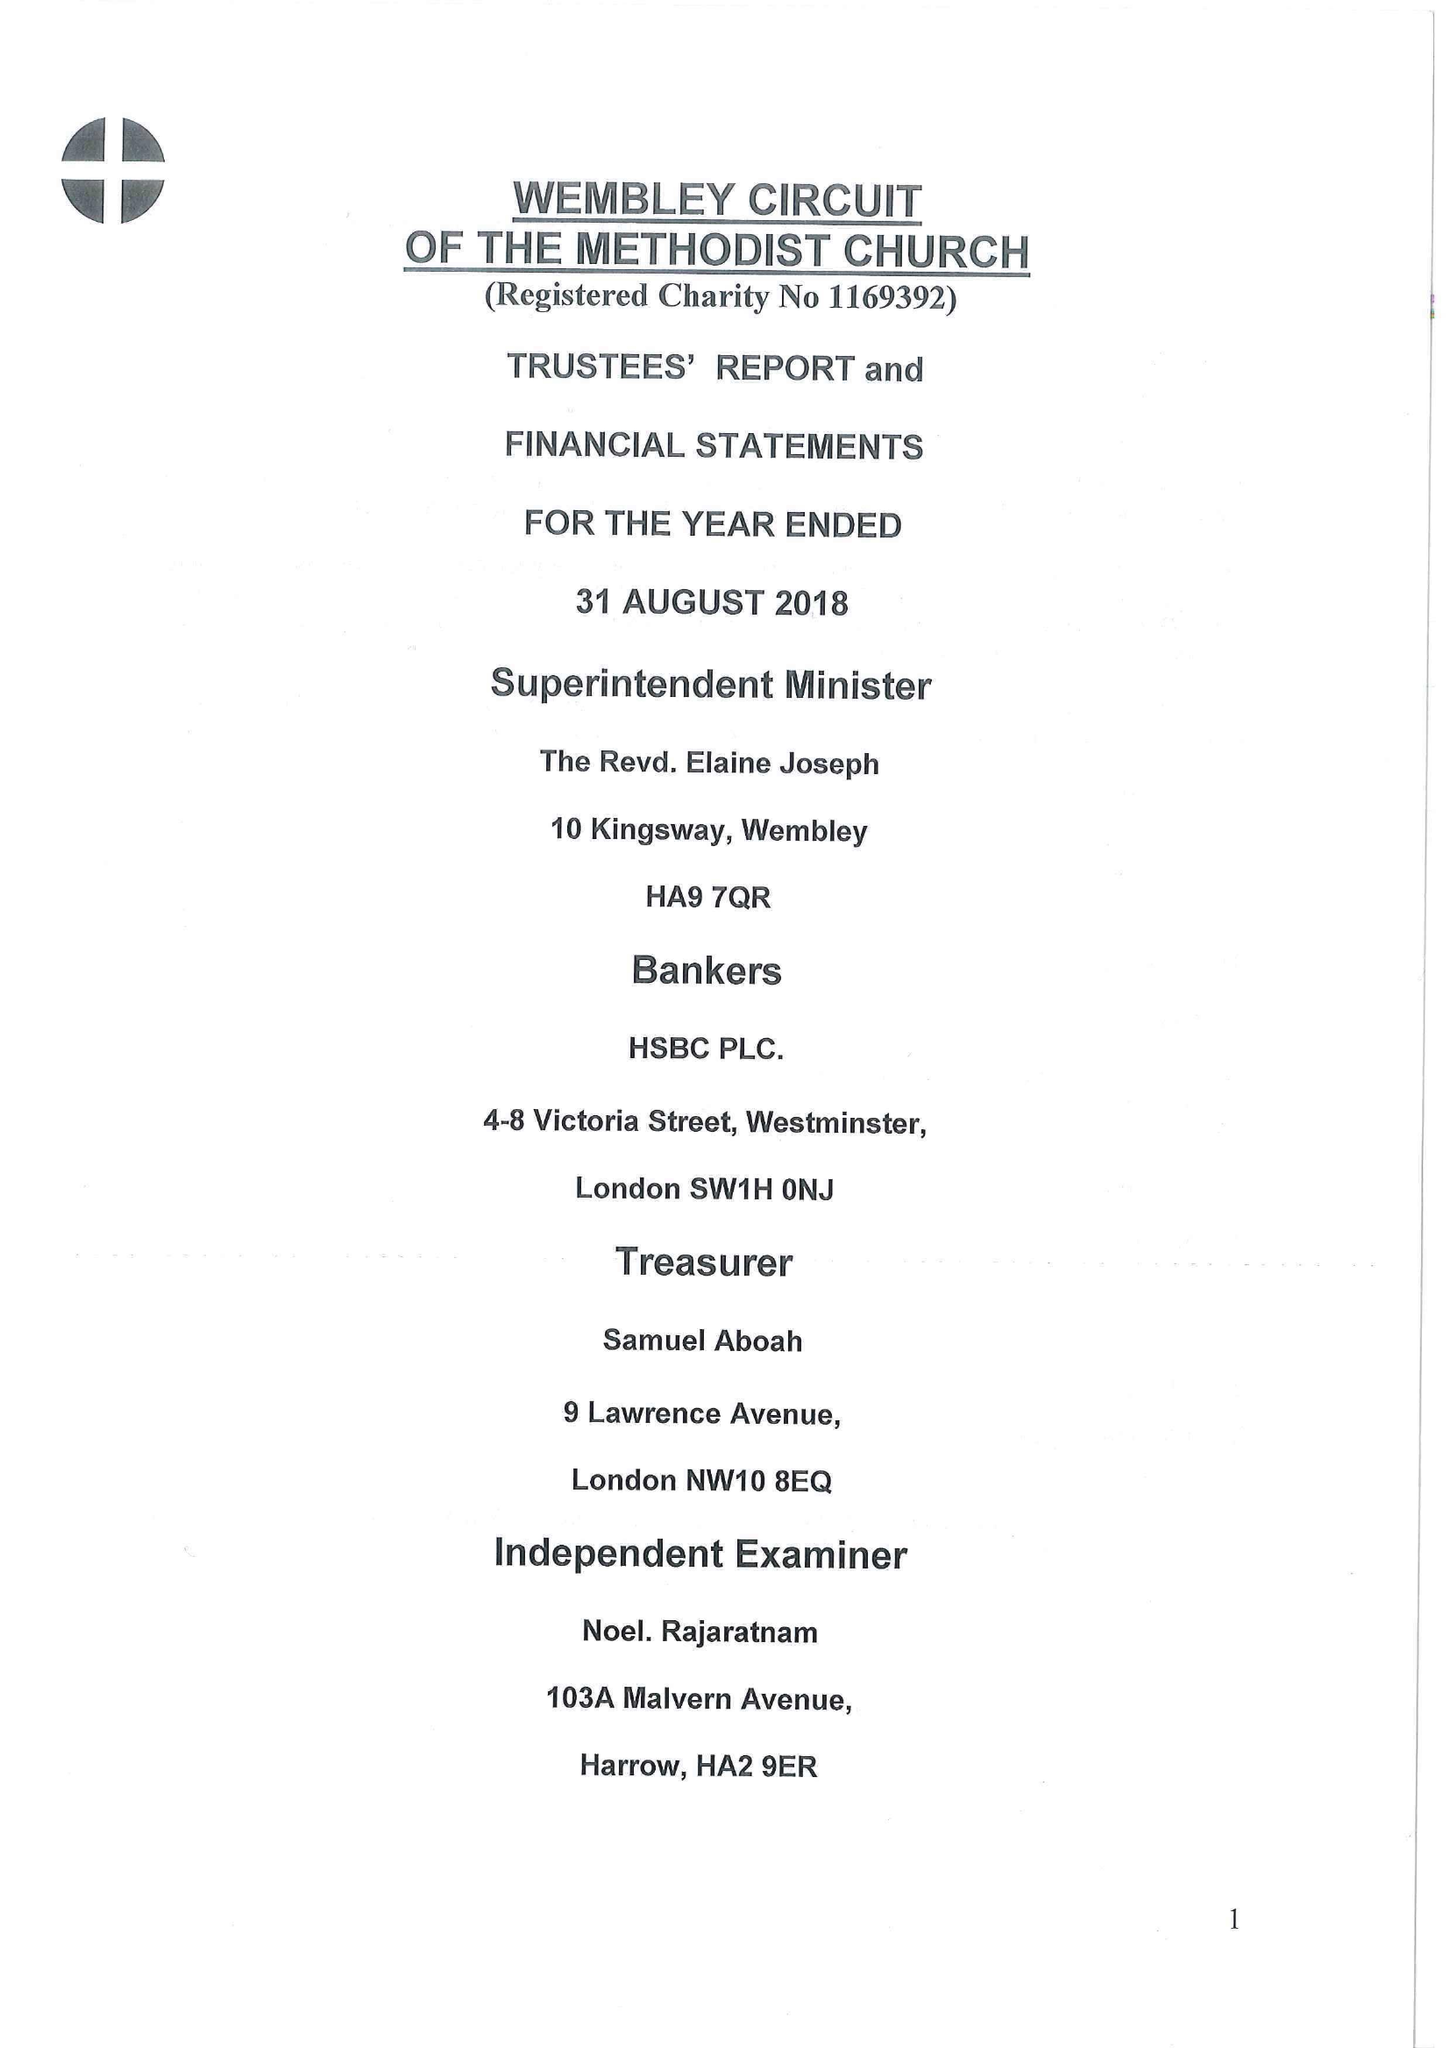What is the value for the income_annually_in_british_pounds?
Answer the question using a single word or phrase. 174599.00 